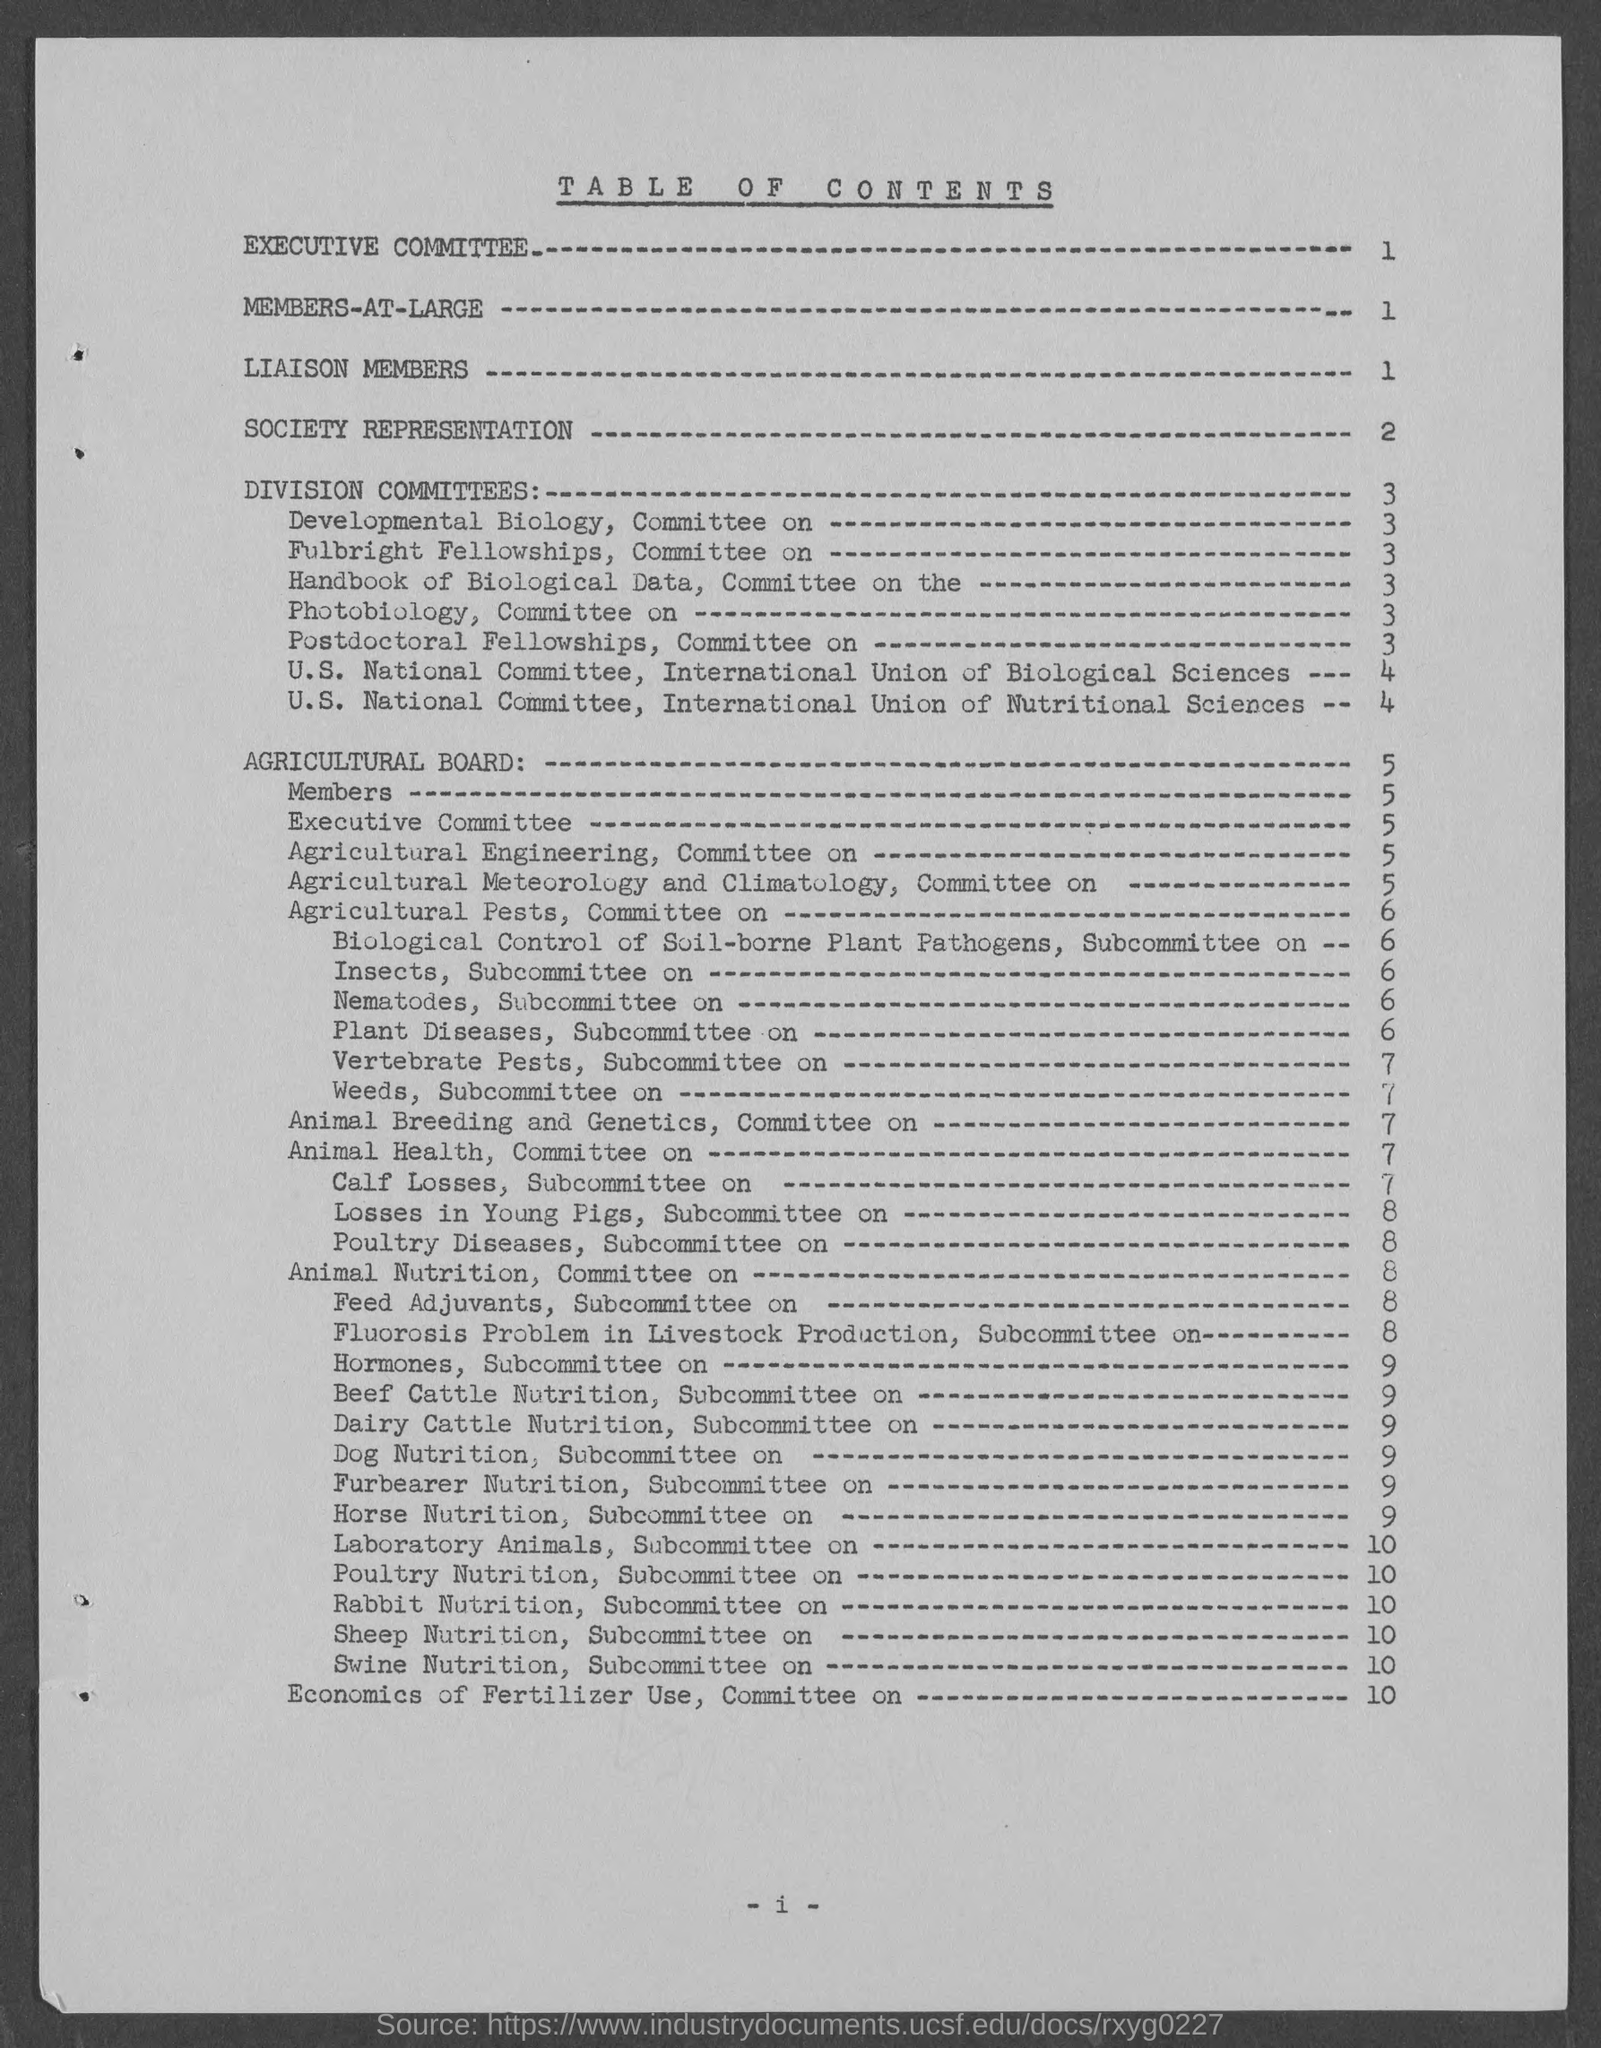Specify some key components in this picture. The title "Society Representation" can be found on page 2. 